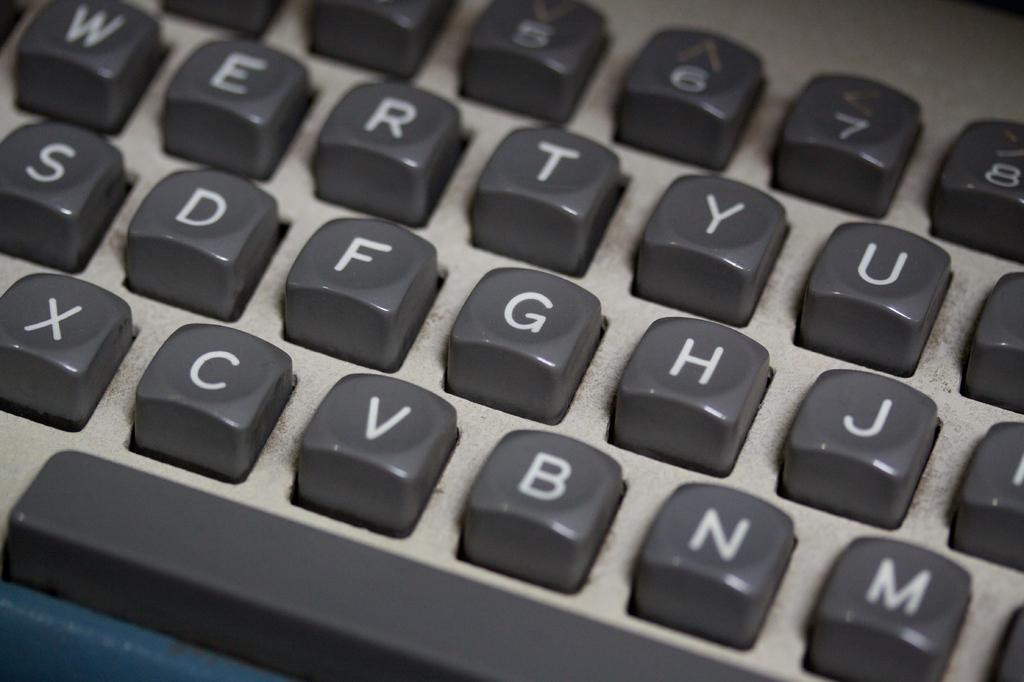<image>
Give a short and clear explanation of the subsequent image. A grey keyboard with white letters on the keys that include X, C, V, B, and N on the bottom row. 